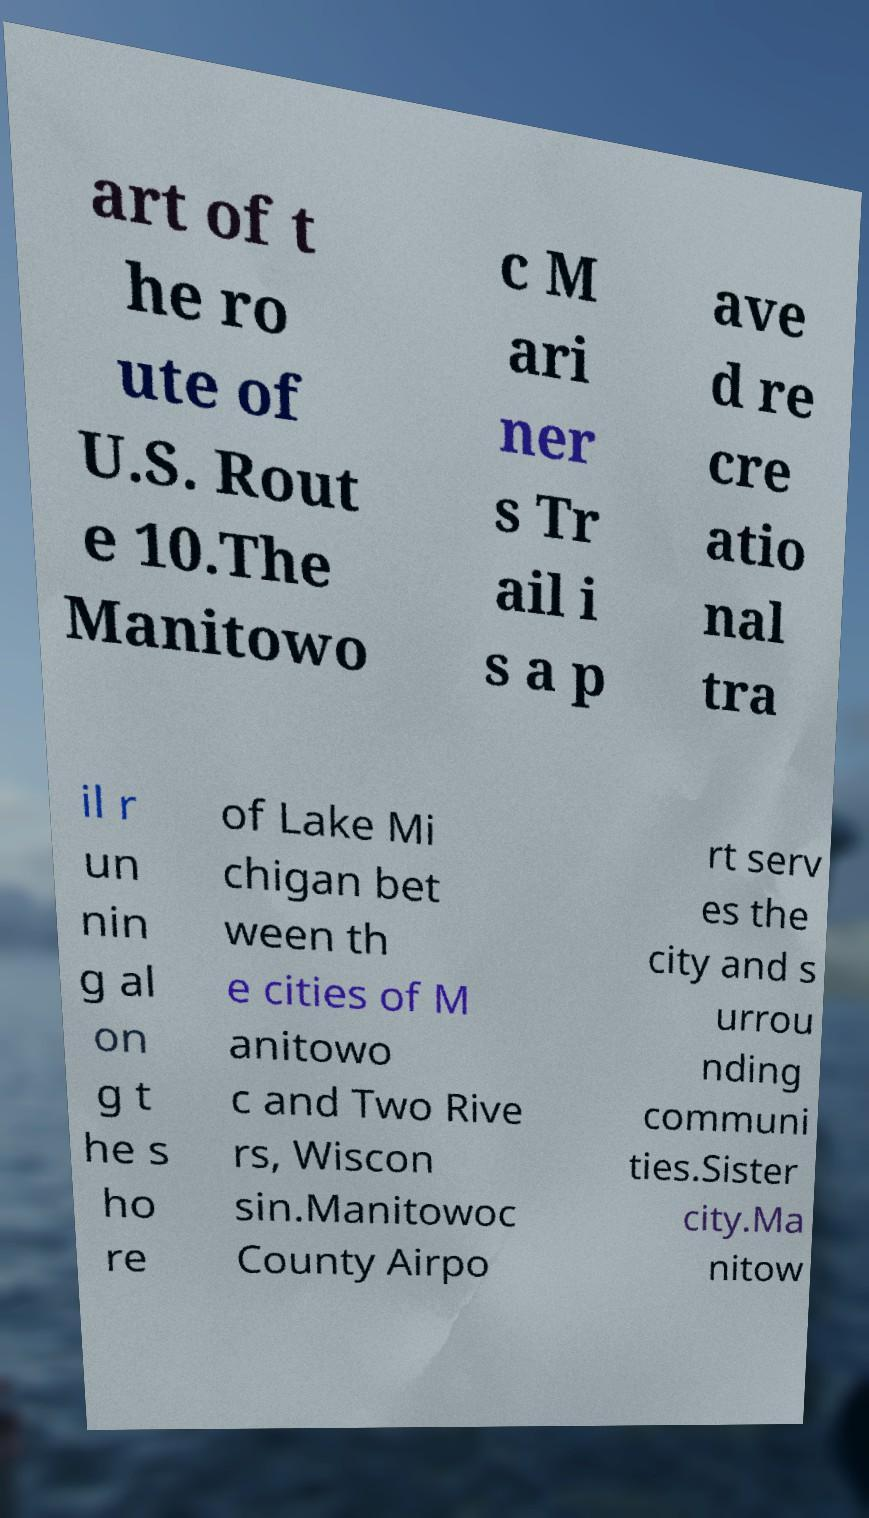Could you assist in decoding the text presented in this image and type it out clearly? art of t he ro ute of U.S. Rout e 10.The Manitowo c M ari ner s Tr ail i s a p ave d re cre atio nal tra il r un nin g al on g t he s ho re of Lake Mi chigan bet ween th e cities of M anitowo c and Two Rive rs, Wiscon sin.Manitowoc County Airpo rt serv es the city and s urrou nding communi ties.Sister city.Ma nitow 